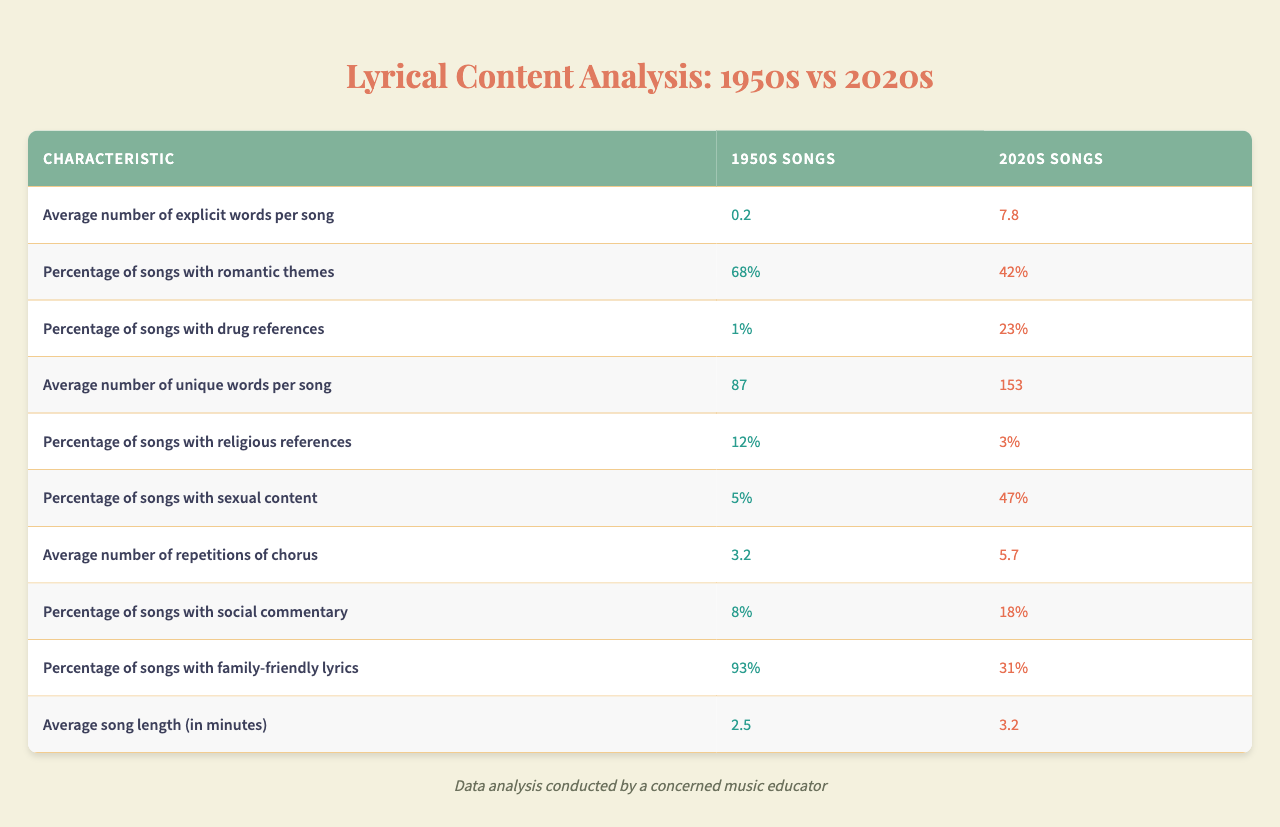What is the average number of explicit words per song in the 2020s? The table shows that the average number of explicit words per song in the 2020s is listed as 7.8.
Answer: 7.8 What percentage of 1950s songs have romantic themes? The table indicates that 68% of the songs from the 1950s contain romantic themes.
Answer: 68% How many unique words are used on average in 2020s songs compared to 1950s songs? In the 2020s, the average number of unique words per song is 153, while in the 1950s, it's 87. The difference is 153 - 87 = 66.
Answer: 66 What is the percentage of songs with sexual content in 1950s music? According to the table, only 5% of songs from the 1950s contain sexual content.
Answer: 5% How many more songs in the 2020s contain drug references compared to the 1950s? In the 1950s, 1% of songs have drug references, whereas in the 2020s, this increases to 23%. The difference is 23% - 1% = 22%.
Answer: 22% Is it true that the average song length is shorter in the 1950s than in the 2020s? The table shows that the average song length in the 1950s is 2.5 minutes and in the 2020s is 3.2 minutes, confirming that the 1950s songs are shorter.
Answer: True What is the increase in the percentage of songs with sexual content from the 1950s to the 2020s? In the 1950s, 5% of songs had sexual content, which rose to 47% in the 2020s. The increase is 47% - 5% = 42%.
Answer: 42% How does the percentage of family-friendly lyrics compare between the two decades? The table shows that 93% of songs in the 1950s are family-friendly compared to only 31% in the 2020s, indicating a significant decline.
Answer: 62% lower in the 2020s What is the average number of repetitions of the chorus in the 1950s songs? The average number of repetitions of the chorus in 1950s songs is 3.2, according to the table.
Answer: 3.2 Which decade has a higher percentage of songs with social commentary? The table indicates that 8% of the 1950s songs contain social commentary, while 18% of the 2020s songs do, showing that the 2020s have a higher percentage.
Answer: 2020s What is the total change in the average number of explicit words from the 1950s to the 2020s? The average increased from 0.2 explicit words in the 1950s to 7.8 in the 2020s. The total increase is 7.8 - 0.2 = 7.6 explicit words.
Answer: 7.6 